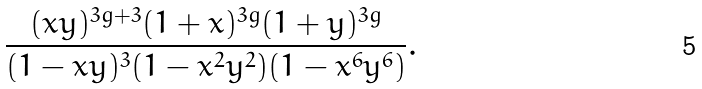Convert formula to latex. <formula><loc_0><loc_0><loc_500><loc_500>\frac { ( x y ) ^ { 3 g + 3 } ( 1 + x ) ^ { 3 g } ( 1 + y ) ^ { 3 g } } { ( 1 - x y ) ^ { 3 } ( 1 - x ^ { 2 } y ^ { 2 } ) ( 1 - x ^ { 6 } y ^ { 6 } ) } .</formula> 